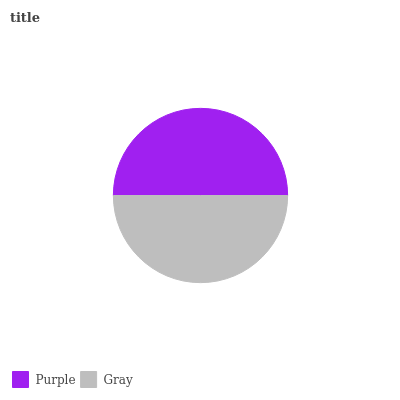Is Gray the minimum?
Answer yes or no. Yes. Is Purple the maximum?
Answer yes or no. Yes. Is Gray the maximum?
Answer yes or no. No. Is Purple greater than Gray?
Answer yes or no. Yes. Is Gray less than Purple?
Answer yes or no. Yes. Is Gray greater than Purple?
Answer yes or no. No. Is Purple less than Gray?
Answer yes or no. No. Is Purple the high median?
Answer yes or no. Yes. Is Gray the low median?
Answer yes or no. Yes. Is Gray the high median?
Answer yes or no. No. Is Purple the low median?
Answer yes or no. No. 